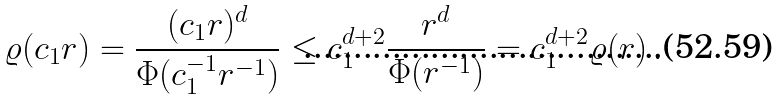Convert formula to latex. <formula><loc_0><loc_0><loc_500><loc_500>\varrho ( c _ { 1 } r ) = \frac { ( c _ { 1 } r ) ^ { d } } { \Phi ( c _ { 1 } ^ { - 1 } r ^ { - 1 } ) } \leq c _ { 1 } ^ { d + 2 } \frac { r ^ { d } } { \Phi ( r ^ { - 1 } ) } = c _ { 1 } ^ { d + 2 } \varrho ( r ) \, .</formula> 